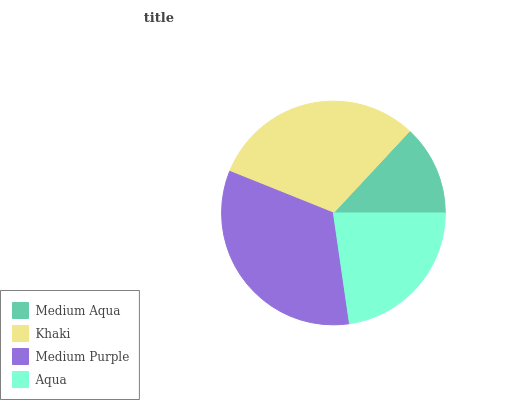Is Medium Aqua the minimum?
Answer yes or no. Yes. Is Medium Purple the maximum?
Answer yes or no. Yes. Is Khaki the minimum?
Answer yes or no. No. Is Khaki the maximum?
Answer yes or no. No. Is Khaki greater than Medium Aqua?
Answer yes or no. Yes. Is Medium Aqua less than Khaki?
Answer yes or no. Yes. Is Medium Aqua greater than Khaki?
Answer yes or no. No. Is Khaki less than Medium Aqua?
Answer yes or no. No. Is Khaki the high median?
Answer yes or no. Yes. Is Aqua the low median?
Answer yes or no. Yes. Is Medium Aqua the high median?
Answer yes or no. No. Is Medium Purple the low median?
Answer yes or no. No. 